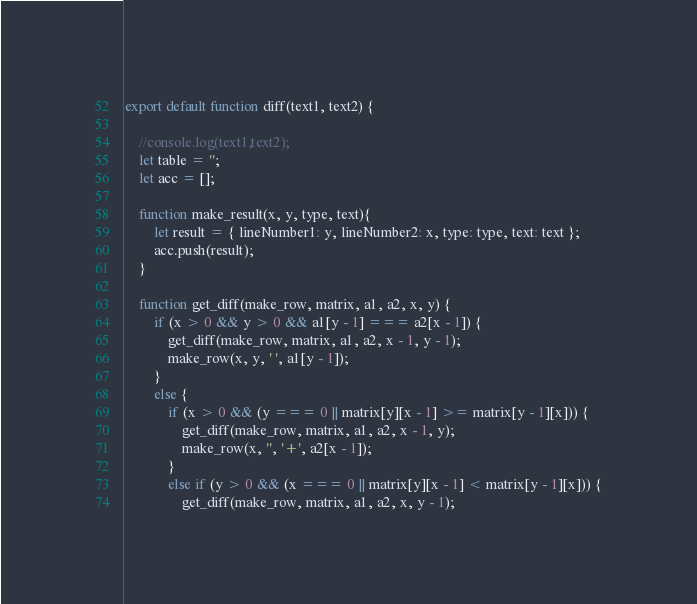<code> <loc_0><loc_0><loc_500><loc_500><_JavaScript_>export default function diff(text1, text2) {
    
    //console.log(text1,text2);
    let table = '';
    let acc = [];

    function make_result(x, y, type, text){
        let result = { lineNumber1: y, lineNumber2: x, type: type, text: text };
        acc.push(result);
    }
   
    function get_diff(make_row, matrix, a1, a2, x, y) {
        if (x > 0 && y > 0 && a1[y - 1] === a2[x - 1]) {
            get_diff(make_row, matrix, a1, a2, x - 1, y - 1);
            make_row(x, y, ' ', a1[y - 1]);
        }
        else {
            if (x > 0 && (y === 0 || matrix[y][x - 1] >= matrix[y - 1][x])) {
                get_diff(make_row, matrix, a1, a2, x - 1, y);
                make_row(x, '', '+', a2[x - 1]);
            }
            else if (y > 0 && (x === 0 || matrix[y][x - 1] < matrix[y - 1][x])) {
                get_diff(make_row, matrix, a1, a2, x, y - 1);</code> 